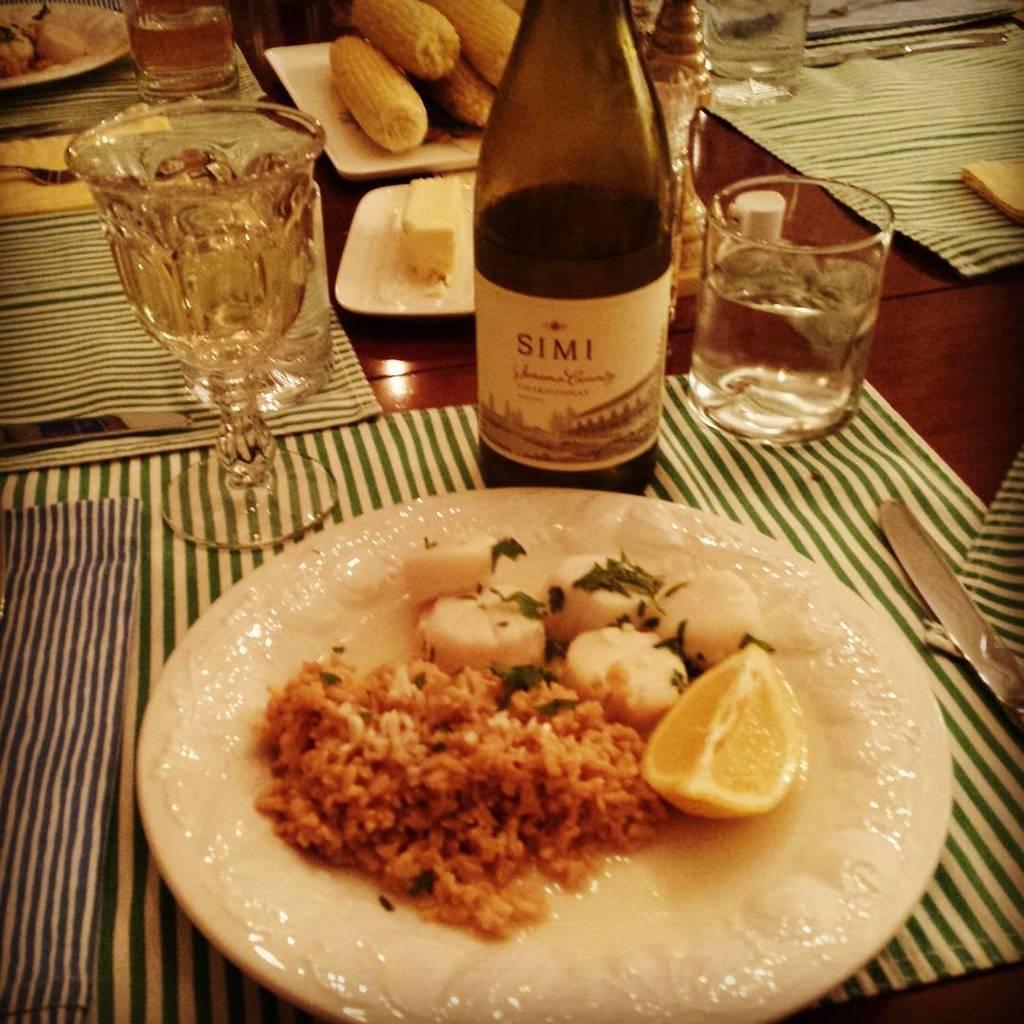Can you describe this image briefly? This is a table. On the table, there are plates, bottle, glasses, trays, on tray there are corns, table mats, and food items, on food item there is a lemon and on the table there is a knife. 